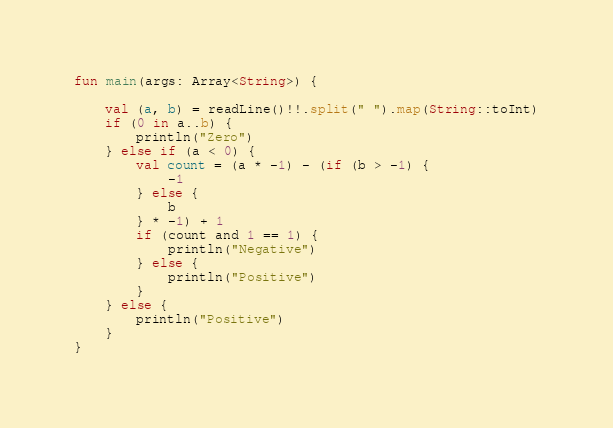Convert code to text. <code><loc_0><loc_0><loc_500><loc_500><_Kotlin_>fun main(args: Array<String>) {

    val (a, b) = readLine()!!.split(" ").map(String::toInt)
    if (0 in a..b) {
        println("Zero")
    } else if (a < 0) {
        val count = (a * -1) - (if (b > -1) {
            -1
        } else {
            b
        } * -1) + 1
        if (count and 1 == 1) {
            println("Negative")
        } else {
            println("Positive")
        }
    } else {
        println("Positive")
    }
}



</code> 